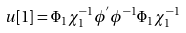Convert formula to latex. <formula><loc_0><loc_0><loc_500><loc_500>u [ 1 ] = \Phi _ { 1 } \chi _ { 1 } ^ { - 1 } \phi ^ { ^ { \prime } } \phi ^ { - 1 } \Phi _ { 1 } \chi ^ { - 1 } _ { 1 }</formula> 